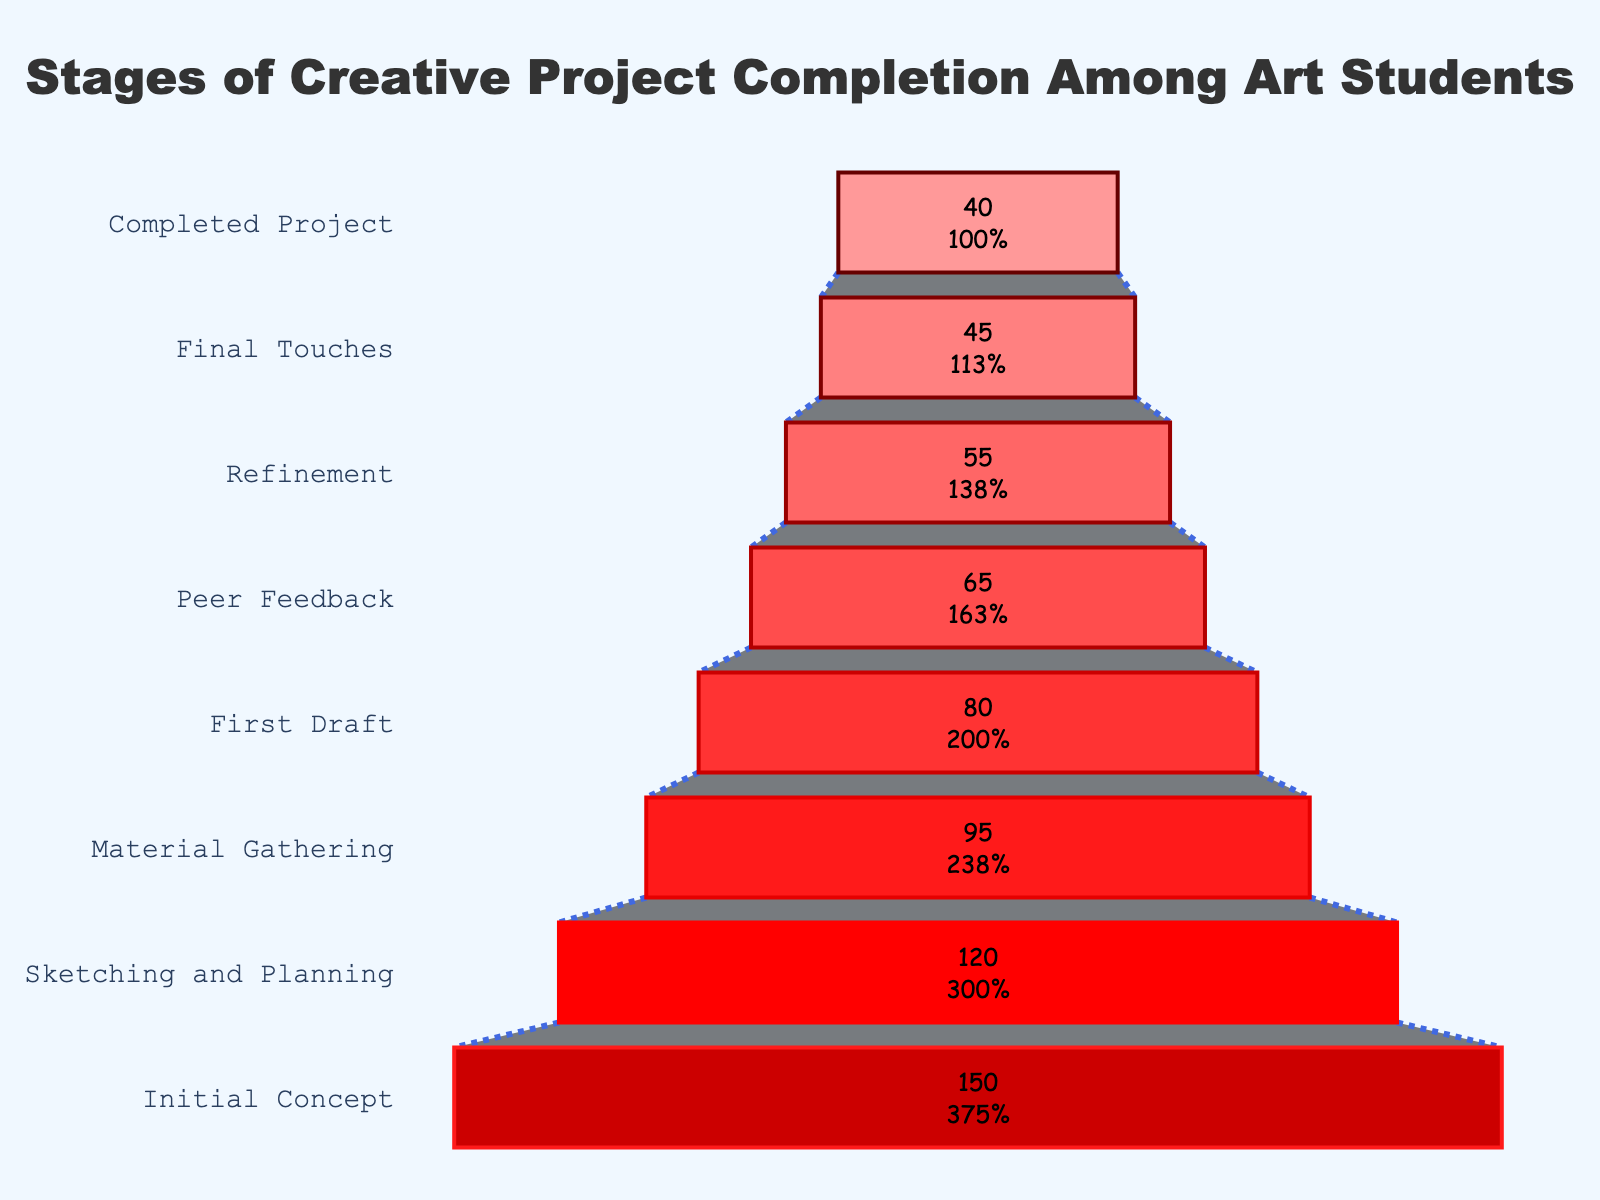What is the title of the funnel chart? The title of the chart is prominently displayed at the top and reads "Stages of Creative Project Completion Among Art Students".
Answer: Stages of Creative Project Completion Among Art Students How many students completed their projects? The number of students in the "Completed Project" stage is shown at the bottom of the funnel.
Answer: 40 What's the difference between the number of students in the "Initial Concept" stage and the "Completed Project" stage? By looking at the chart, we can see that the "Initial Concept" stage has 150 students, and the "Completed Project" stage has 40 students. The difference is 150 - 40.
Answer: 110 How many stages are there in the creative project completion process? The stages are listed on the y-axis of the funnel chart, and we can count them.
Answer: 8 Which stage loses the most students compared to the previous stage? To find which stage has the largest drop, compare the differences between consecutive stages: "Initial Concept" (150) to "Sketching and Planning" (120), a difference of 30, "Sketching and Planning" (120) to "Material Gathering" (95), a difference of 25, and so on. The largest drop is from "Initial Concept" to "Sketching and Planning" (30).
Answer: Sketching and Planning What percentage of students reached the "First Draft" stage? The "First Draft" stage has 80 students out of the initial 150. Calculate the percentage: (80/150)*100.
Answer: 53.3% What is the average number of students across all stages? Add the number of students in each stage and divide by the total number of stages: (150 + 120 + 95 + 80 + 65 + 55 + 45 + 40) / 8.
Answer: 81.25 Which stage has fewer students: "Peer Feedback" or "Refinement"? Compare the number of students in "Peer Feedback" (65) to "Refinement" (55).
Answer: Refinement What stage follows "Material Gathering"? The stages are listed sequentially on the y-axis of the funnel chart. "First Draft" follows "Material Gathering".
Answer: First Draft What is the color used for the "Final Touches" stage in the funnel chart? By observing the funnel chart, we see that "Final Touches" is colored in a dark red shade.
Answer: Dark red 